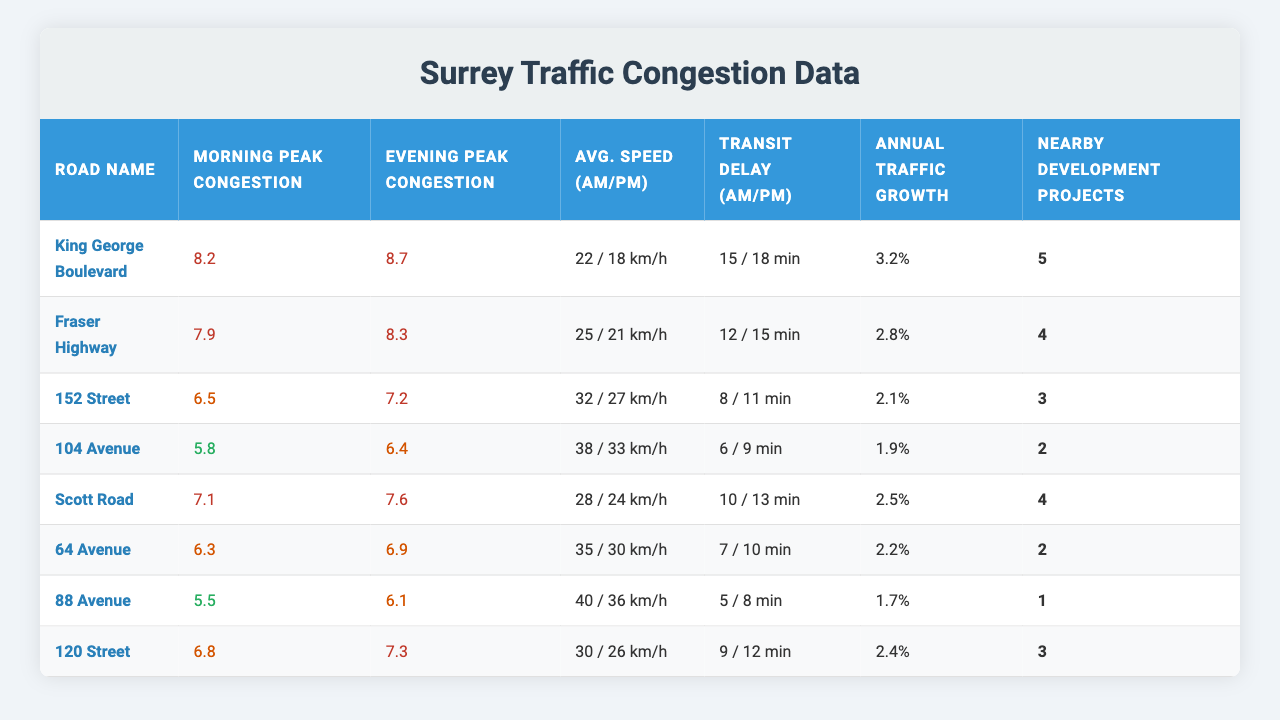What is the morning peak congestion level on King George Boulevard? The table shows the morning peak congestion level for King George Boulevard as 8.2.
Answer: 8.2 What is the average speed during evening peak hours on 152 Street? The average speed during evening peak hours for 152 Street is 27 km/h, as seen in the table.
Answer: 27 km/h Which road has the highest evening peak congestion level? The highest evening peak congestion level is 8.7 on King George Boulevard, according to the table data.
Answer: King George Boulevard What is the total number of nearby development projects on Fraser Highway and Scott Road combined? Fraser Highway has 4 nearby development projects, and Scott Road has 4. So, adding them gives 4 + 4 = 8.
Answer: 8 How much higher is the morning peak congestion level on 88 Avenue than on 64 Avenue? Morning peak congestion level on 88 Avenue is 5.5 and on 64 Avenue it is 6.3. The difference is 6.3 - 5.5 = 0.8.
Answer: 0.8 Is the annual traffic growth percent higher on 104 Avenue than on 152 Street? The annual traffic growth percentage for 104 Avenue is 1.9%, and for 152 Street, it is 2.1%. Since 1.9% is less than 2.1%, the answer is no.
Answer: No What is the average morning peak congestion level for all roads listed in the table? To find the average, sum the morning peak congestion levels (8.2 + 7.9 + 6.5 + 5.8 + 7.1 + 6.3 + 5.5 + 6.8) = 54.1, and divide by 8, which equals 6.76.
Answer: 6.76 Which road has the lowest transit delay minutes in the morning? The table indicates that 88 Avenue has the lowest transit delay at 5 minutes during the morning.
Answer: 88 Avenue What is the ratio of evening to morning average speed for Scott Road? For Scott Road, the average speed during morning peak hours is 28 km/h and during evening peak hours is 24 km/h. The ratio is 28:24, which simplifies to 7:6.
Answer: 7:6 Which road has the lowest annual traffic growth percentage? The data shows that 88 Avenue has the lowest annual traffic growth percentage at 1.7%.
Answer: 88 Avenue 